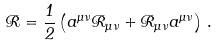Convert formula to latex. <formula><loc_0><loc_0><loc_500><loc_500>\mathcal { R } = \frac { 1 } { 2 } \left ( a ^ { \mu \nu } \mathcal { R } _ { \mu \nu } + \mathcal { R } _ { \mu \nu } a ^ { \mu \nu } \right ) \, .</formula> 